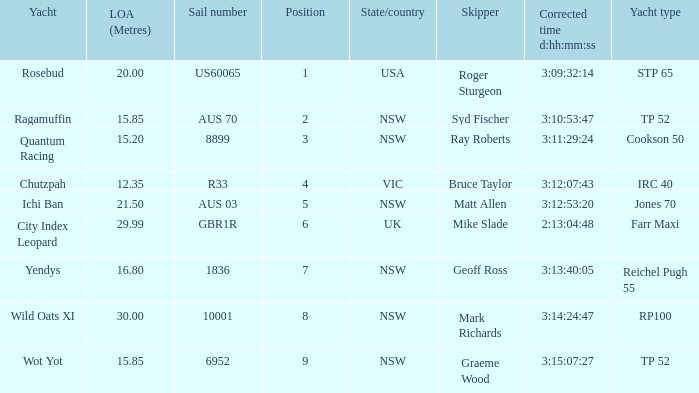What are all sail numbers for the yacht Yendys? 1836.0. 